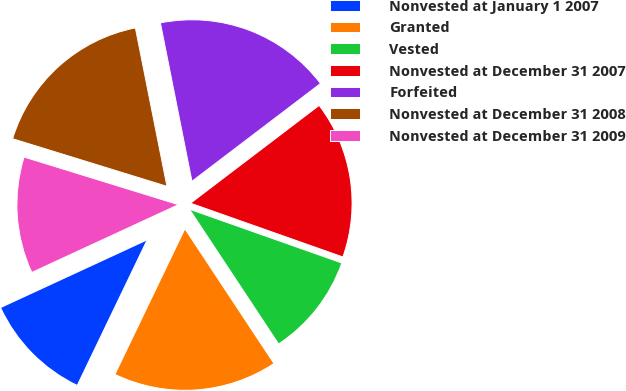<chart> <loc_0><loc_0><loc_500><loc_500><pie_chart><fcel>Nonvested at January 1 2007<fcel>Granted<fcel>Vested<fcel>Nonvested at December 31 2007<fcel>Forfeited<fcel>Nonvested at December 31 2008<fcel>Nonvested at December 31 2009<nl><fcel>10.98%<fcel>16.43%<fcel>10.3%<fcel>15.75%<fcel>17.78%<fcel>17.11%<fcel>11.65%<nl></chart> 